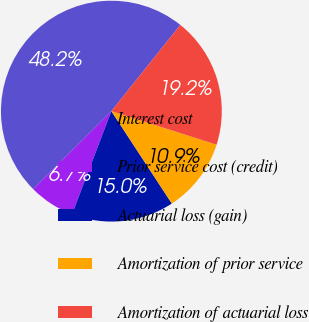Convert chart to OTSL. <chart><loc_0><loc_0><loc_500><loc_500><pie_chart><fcel>Interest cost<fcel>Prior service cost (credit)<fcel>Actuarial loss (gain)<fcel>Amortization of prior service<fcel>Amortization of actuarial loss<nl><fcel>48.22%<fcel>6.72%<fcel>15.02%<fcel>10.87%<fcel>19.17%<nl></chart> 